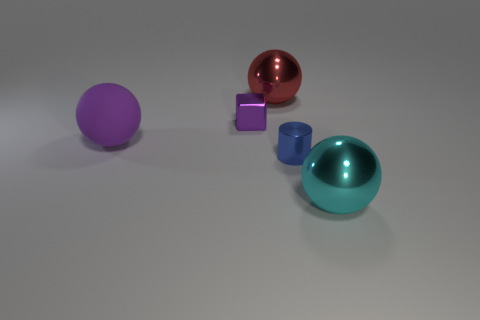What is the material of the large object that is the same color as the block?
Your response must be concise. Rubber. There is a large metal thing that is in front of the shiny sphere behind the cyan metallic object; what shape is it?
Your response must be concise. Sphere. Is there a small gray shiny object that has the same shape as the blue metallic thing?
Your response must be concise. No. What number of large rubber cubes are there?
Ensure brevity in your answer.  0. Are the tiny thing that is in front of the purple ball and the purple ball made of the same material?
Give a very brief answer. No. Are there any purple matte balls of the same size as the purple block?
Give a very brief answer. No. Is the shape of the big cyan thing the same as the rubber object on the left side of the small blue cylinder?
Give a very brief answer. Yes. There is a big metallic sphere on the left side of the large ball on the right side of the blue metal cylinder; is there a small shiny thing to the left of it?
Provide a short and direct response. Yes. What is the size of the matte thing?
Ensure brevity in your answer.  Large. How many other objects are the same color as the small cylinder?
Ensure brevity in your answer.  0. 